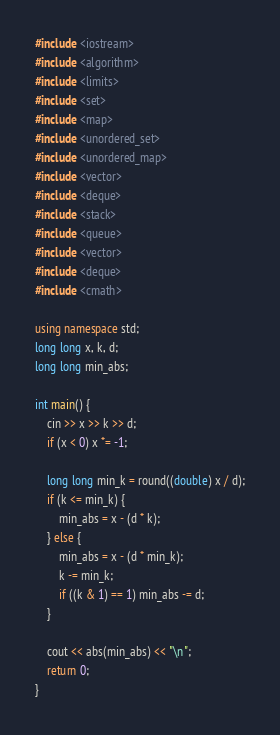Convert code to text. <code><loc_0><loc_0><loc_500><loc_500><_C++_>#include <iostream>
#include <algorithm>
#include <limits>
#include <set>
#include <map>
#include <unordered_set>
#include <unordered_map>
#include <vector>
#include <deque>
#include <stack>
#include <queue>
#include <vector>
#include <deque>
#include <cmath>

using namespace std;
long long x, k, d;
long long min_abs;

int main() {
    cin >> x >> k >> d;
    if (x < 0) x *= -1;

    long long min_k = round((double) x / d);
    if (k <= min_k) {
        min_abs = x - (d * k);
    } else {
        min_abs = x - (d * min_k);
        k -= min_k;
        if ((k & 1) == 1) min_abs -= d;
    }

    cout << abs(min_abs) << "\n";
    return 0;
}
</code> 